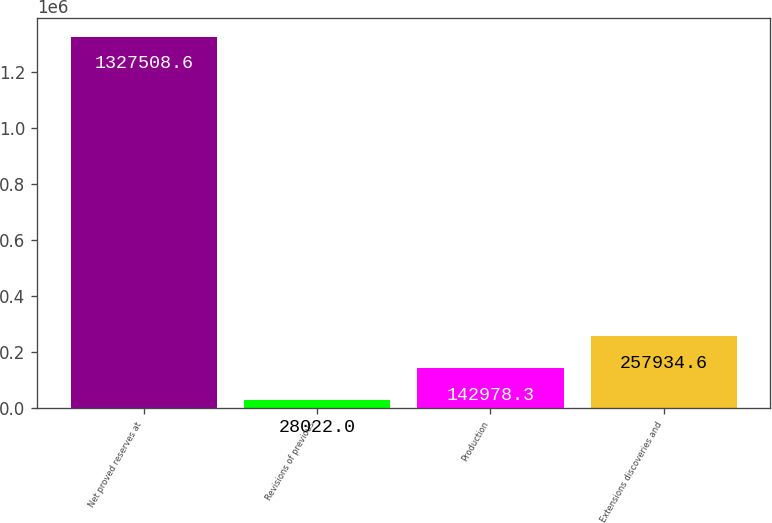<chart> <loc_0><loc_0><loc_500><loc_500><bar_chart><fcel>Net proved reserves at<fcel>Revisions of previous<fcel>Production<fcel>Extensions discoveries and<nl><fcel>1.32751e+06<fcel>28022<fcel>142978<fcel>257935<nl></chart> 